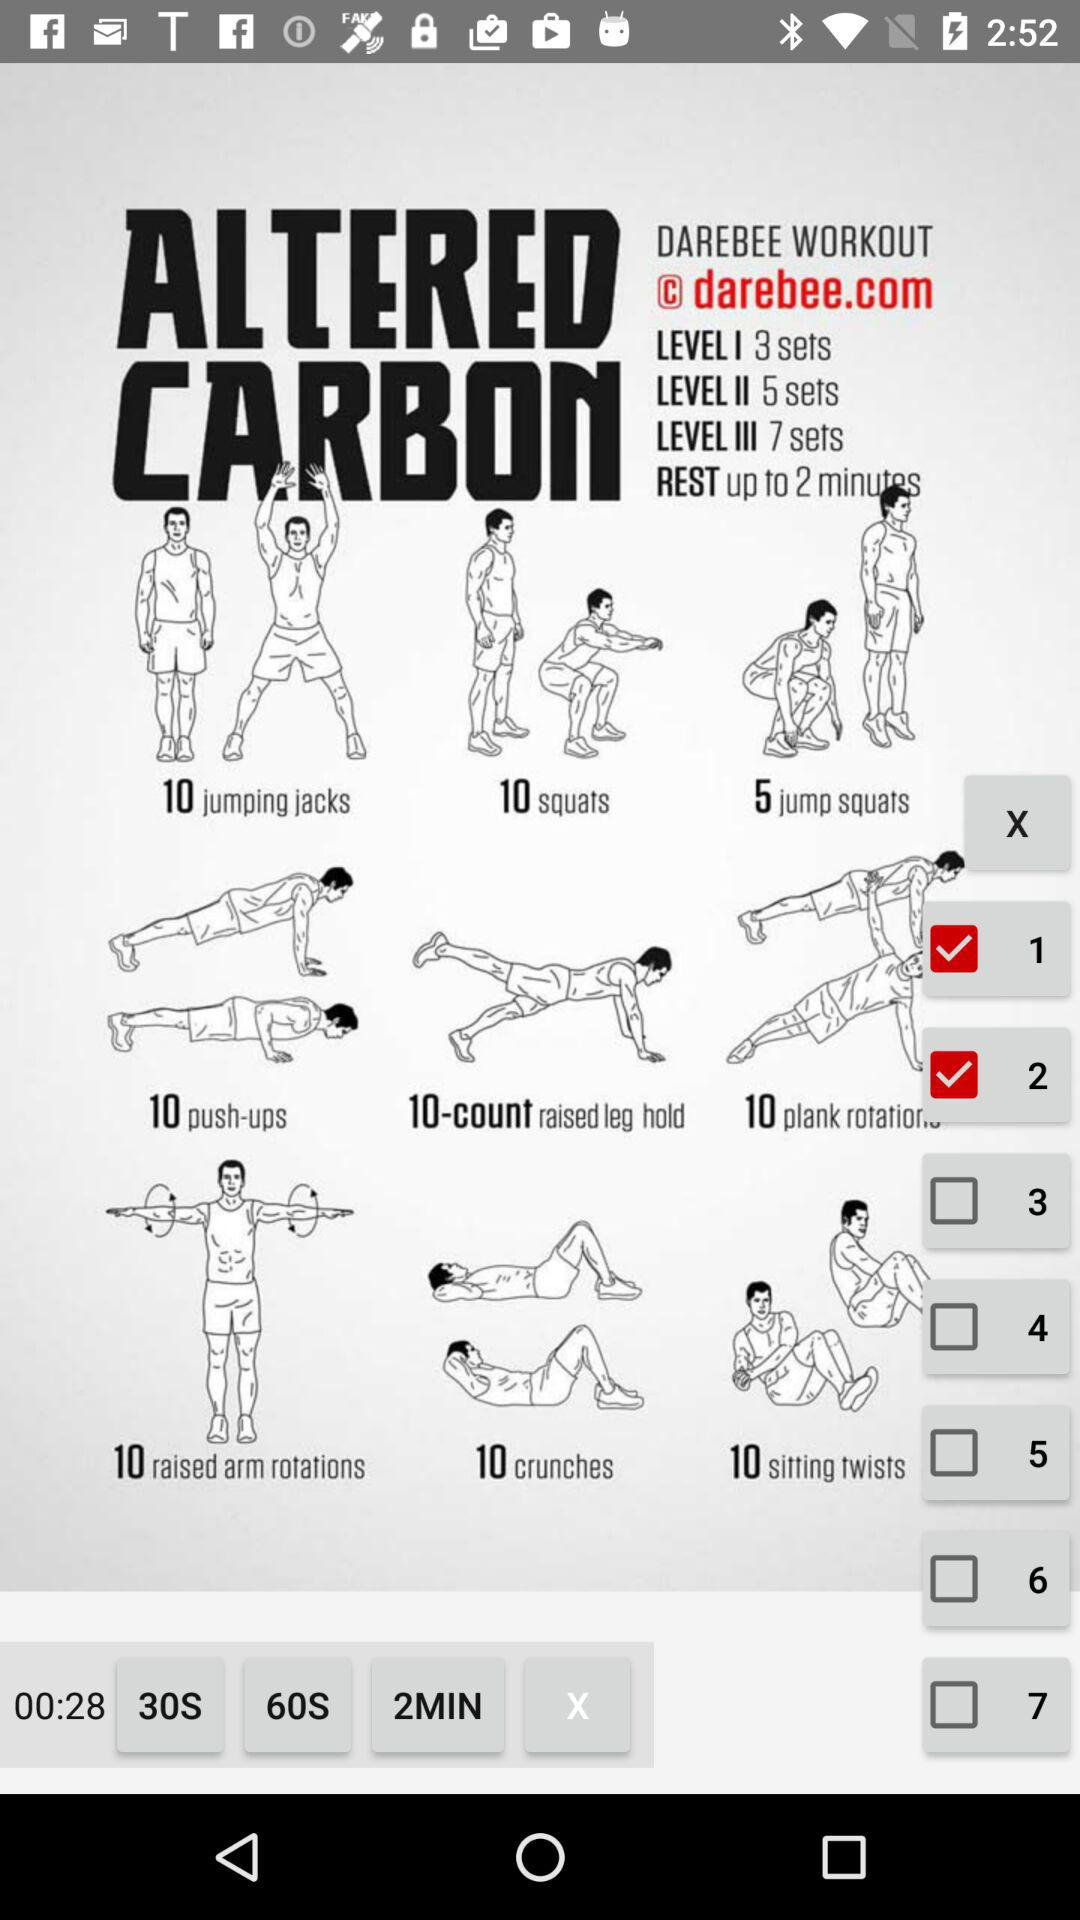How many sets are there for level 3? There are 7 sets for level 3. 